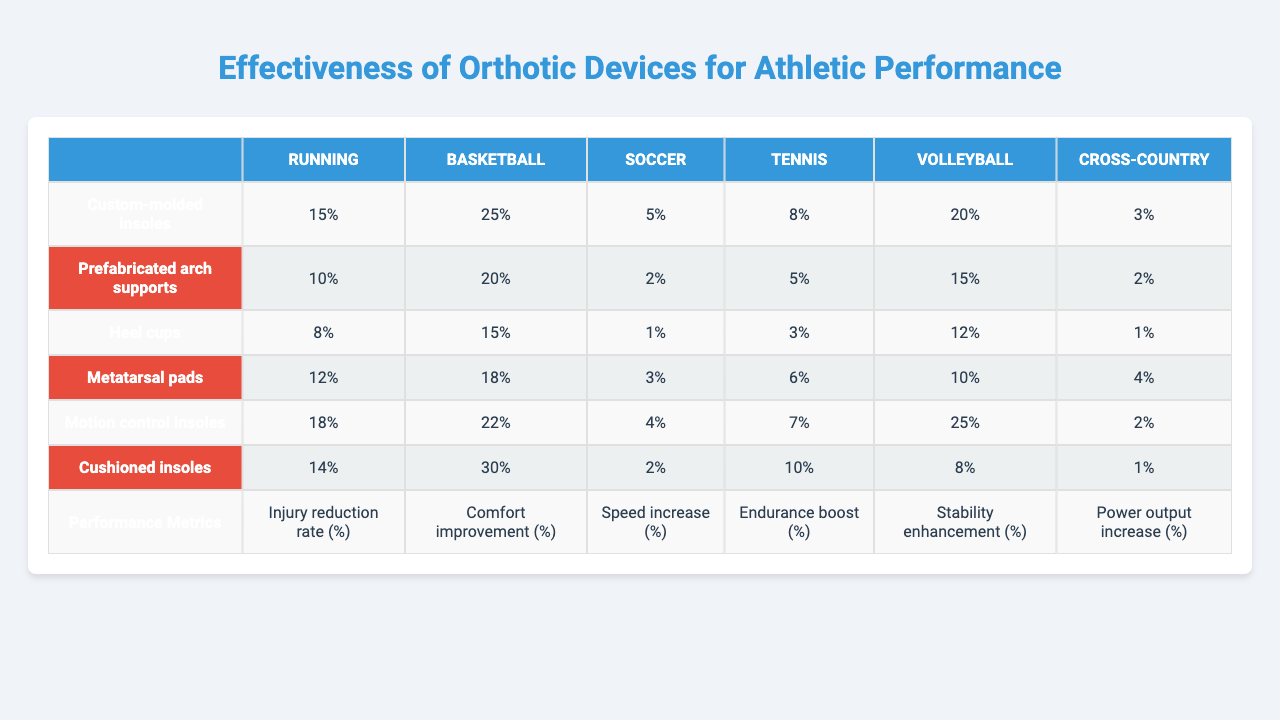What is the injury reduction rate for custom-molded insoles in running? The injury reduction rate for custom-molded insoles in running is listed in the table as 15%.
Answer: 15% Which orthotic device offers the highest percentage for comfort improvement in basketball? For basketball, the highest comfort improvement percentage is provided by cushioned insoles at 30%.
Answer: 30% What is the difference in speed increase percentage between heel cups and motion control insoles in soccer? The speed increase for heel cups in soccer is 1%, while motion control insoles show 4%. The difference is 4% - 1% = 3%.
Answer: 3% Which orthotic device improves endurance the most in volleyball? The table shows that the device with the highest endurance boost in volleyball is the custom-molded insoles, with an improvement of 10%.
Answer: 10% Are prefabricated arch supports effective in reducing injuries in any athletic activities? Yes, prefabricated arch supports have an injury reduction rate of 10% in running, 20% in basketball, and 2% in soccer.
Answer: Yes What is the average stability enhancement percentage across all orthotic devices? To find the average, sum the stability enhancement percentages: (20 + 15 + 12 + 10 + 25 + 8) = 90, and then divide by 6. The average is 90 / 6 = 15%.
Answer: 15% Which orthotic device shows a power output increase of 4% or more while used for tennis? The table indicates that heel cups show a power output increase of 4% for tennis.
Answer: 4% For which athletic activity do metatarsal pads have the lowest effectiveness in terms of injury reduction? The metatarsal pads show the lowest injury reduction rate of 3% in tennis.
Answer: 3% What is the total percentage improvement for custom-molded insoles across all performance metrics? For custom-molded insoles, the improvements are 15% (injury reduction) + 25% (comfort) + 5% (speed) + 8% (endurance) + 20% (stability) + 3% (power), totaling 76%.
Answer: 76% Do cushioned insoles provide any improvement in speed for cross-country activities? The table shows that cushioned insoles provide a speed increase of 1% for cross-country activities.
Answer: 1% 